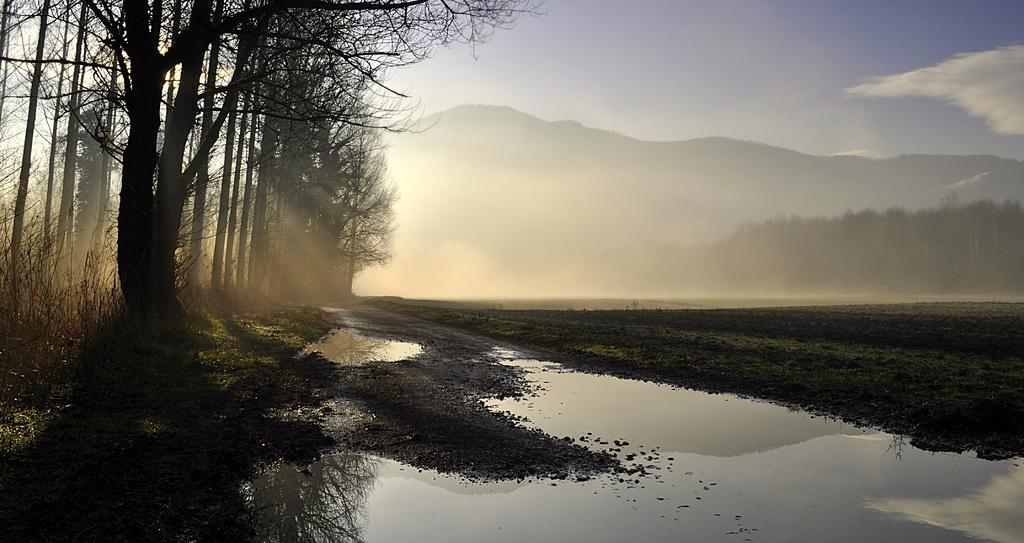Could you give a brief overview of what you see in this image? In this picture there are mountains and trees. At the top there is sky and there are clouds. At the bottom there is water and there is grass and ground and there is a sun light. 